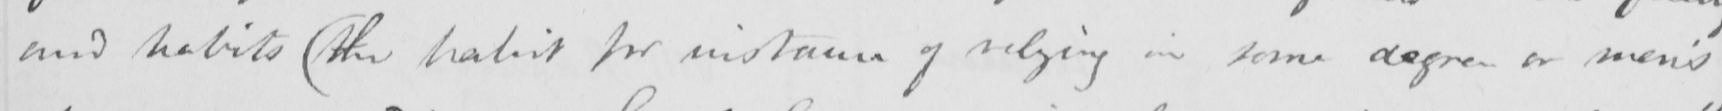What does this handwritten line say? and habits  ( the habit for instance of relying in some degree on men ' s 